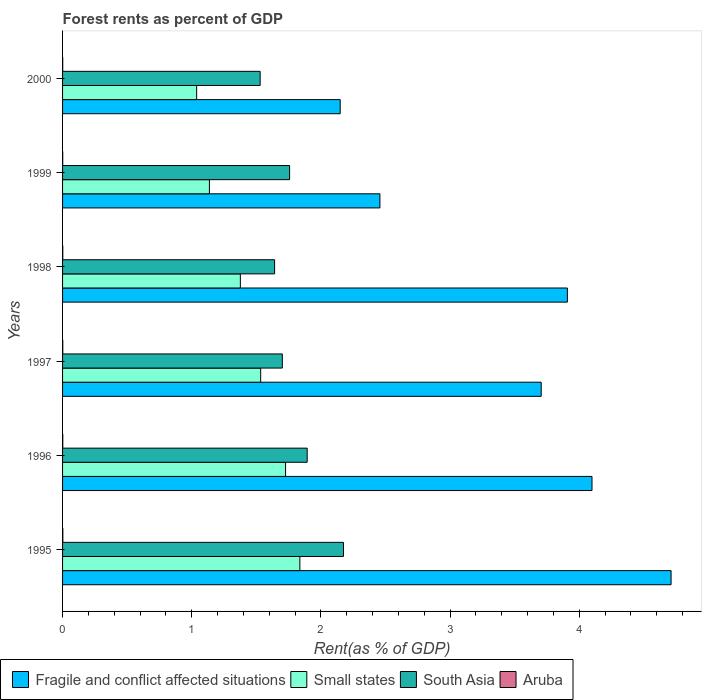How many groups of bars are there?
Your response must be concise. 6. Are the number of bars per tick equal to the number of legend labels?
Your answer should be compact. Yes. Are the number of bars on each tick of the Y-axis equal?
Your response must be concise. Yes. How many bars are there on the 2nd tick from the top?
Give a very brief answer. 4. What is the label of the 2nd group of bars from the top?
Give a very brief answer. 1999. What is the forest rent in Aruba in 1997?
Ensure brevity in your answer.  0. Across all years, what is the maximum forest rent in South Asia?
Give a very brief answer. 2.17. Across all years, what is the minimum forest rent in Aruba?
Offer a very short reply. 0. In which year was the forest rent in South Asia maximum?
Your response must be concise. 1995. What is the total forest rent in Small states in the graph?
Provide a succinct answer. 8.65. What is the difference between the forest rent in Aruba in 1997 and that in 2000?
Your answer should be very brief. 0. What is the difference between the forest rent in Aruba in 1997 and the forest rent in Small states in 1999?
Provide a succinct answer. -1.14. What is the average forest rent in Fragile and conflict affected situations per year?
Make the answer very short. 3.5. In the year 1996, what is the difference between the forest rent in South Asia and forest rent in Aruba?
Ensure brevity in your answer.  1.89. In how many years, is the forest rent in Fragile and conflict affected situations greater than 0.4 %?
Ensure brevity in your answer.  6. What is the ratio of the forest rent in South Asia in 1999 to that in 2000?
Your answer should be very brief. 1.15. What is the difference between the highest and the second highest forest rent in Fragile and conflict affected situations?
Provide a short and direct response. 0.61. What is the difference between the highest and the lowest forest rent in South Asia?
Your answer should be compact. 0.65. In how many years, is the forest rent in Aruba greater than the average forest rent in Aruba taken over all years?
Provide a succinct answer. 4. What does the 1st bar from the bottom in 1998 represents?
Your response must be concise. Fragile and conflict affected situations. Is it the case that in every year, the sum of the forest rent in Aruba and forest rent in Small states is greater than the forest rent in Fragile and conflict affected situations?
Your response must be concise. No. How many bars are there?
Provide a short and direct response. 24. Are all the bars in the graph horizontal?
Your response must be concise. Yes. How many years are there in the graph?
Offer a very short reply. 6. Does the graph contain any zero values?
Your answer should be compact. No. Does the graph contain grids?
Offer a very short reply. No. Where does the legend appear in the graph?
Your response must be concise. Bottom left. How many legend labels are there?
Your answer should be compact. 4. What is the title of the graph?
Your answer should be compact. Forest rents as percent of GDP. Does "Burundi" appear as one of the legend labels in the graph?
Your answer should be compact. No. What is the label or title of the X-axis?
Offer a terse response. Rent(as % of GDP). What is the label or title of the Y-axis?
Make the answer very short. Years. What is the Rent(as % of GDP) in Fragile and conflict affected situations in 1995?
Make the answer very short. 4.71. What is the Rent(as % of GDP) of Small states in 1995?
Provide a short and direct response. 1.84. What is the Rent(as % of GDP) in South Asia in 1995?
Your response must be concise. 2.17. What is the Rent(as % of GDP) in Aruba in 1995?
Provide a short and direct response. 0. What is the Rent(as % of GDP) of Fragile and conflict affected situations in 1996?
Provide a succinct answer. 4.1. What is the Rent(as % of GDP) in Small states in 1996?
Provide a succinct answer. 1.73. What is the Rent(as % of GDP) in South Asia in 1996?
Give a very brief answer. 1.89. What is the Rent(as % of GDP) of Aruba in 1996?
Your response must be concise. 0. What is the Rent(as % of GDP) of Fragile and conflict affected situations in 1997?
Provide a short and direct response. 3.71. What is the Rent(as % of GDP) in Small states in 1997?
Ensure brevity in your answer.  1.53. What is the Rent(as % of GDP) in South Asia in 1997?
Your response must be concise. 1.7. What is the Rent(as % of GDP) in Aruba in 1997?
Keep it short and to the point. 0. What is the Rent(as % of GDP) in Fragile and conflict affected situations in 1998?
Your answer should be very brief. 3.91. What is the Rent(as % of GDP) of Small states in 1998?
Offer a terse response. 1.38. What is the Rent(as % of GDP) in South Asia in 1998?
Offer a very short reply. 1.64. What is the Rent(as % of GDP) of Aruba in 1998?
Give a very brief answer. 0. What is the Rent(as % of GDP) of Fragile and conflict affected situations in 1999?
Offer a terse response. 2.46. What is the Rent(as % of GDP) of Small states in 1999?
Keep it short and to the point. 1.14. What is the Rent(as % of GDP) of South Asia in 1999?
Provide a succinct answer. 1.76. What is the Rent(as % of GDP) of Aruba in 1999?
Your answer should be very brief. 0. What is the Rent(as % of GDP) of Fragile and conflict affected situations in 2000?
Your response must be concise. 2.15. What is the Rent(as % of GDP) in Small states in 2000?
Ensure brevity in your answer.  1.04. What is the Rent(as % of GDP) of South Asia in 2000?
Your response must be concise. 1.53. What is the Rent(as % of GDP) of Aruba in 2000?
Offer a terse response. 0. Across all years, what is the maximum Rent(as % of GDP) in Fragile and conflict affected situations?
Provide a succinct answer. 4.71. Across all years, what is the maximum Rent(as % of GDP) in Small states?
Offer a very short reply. 1.84. Across all years, what is the maximum Rent(as % of GDP) in South Asia?
Provide a short and direct response. 2.17. Across all years, what is the maximum Rent(as % of GDP) in Aruba?
Your answer should be compact. 0. Across all years, what is the minimum Rent(as % of GDP) of Fragile and conflict affected situations?
Your answer should be compact. 2.15. Across all years, what is the minimum Rent(as % of GDP) in Small states?
Keep it short and to the point. 1.04. Across all years, what is the minimum Rent(as % of GDP) of South Asia?
Offer a very short reply. 1.53. Across all years, what is the minimum Rent(as % of GDP) of Aruba?
Ensure brevity in your answer.  0. What is the total Rent(as % of GDP) of Fragile and conflict affected situations in the graph?
Your answer should be very brief. 21.03. What is the total Rent(as % of GDP) in Small states in the graph?
Give a very brief answer. 8.65. What is the total Rent(as % of GDP) of South Asia in the graph?
Provide a short and direct response. 10.7. What is the total Rent(as % of GDP) of Aruba in the graph?
Your response must be concise. 0.01. What is the difference between the Rent(as % of GDP) of Fragile and conflict affected situations in 1995 and that in 1996?
Make the answer very short. 0.61. What is the difference between the Rent(as % of GDP) in Small states in 1995 and that in 1996?
Keep it short and to the point. 0.11. What is the difference between the Rent(as % of GDP) in South Asia in 1995 and that in 1996?
Provide a short and direct response. 0.28. What is the difference between the Rent(as % of GDP) in Fragile and conflict affected situations in 1995 and that in 1997?
Offer a very short reply. 1.01. What is the difference between the Rent(as % of GDP) in Small states in 1995 and that in 1997?
Offer a very short reply. 0.3. What is the difference between the Rent(as % of GDP) of South Asia in 1995 and that in 1997?
Give a very brief answer. 0.47. What is the difference between the Rent(as % of GDP) in Fragile and conflict affected situations in 1995 and that in 1998?
Keep it short and to the point. 0.8. What is the difference between the Rent(as % of GDP) in Small states in 1995 and that in 1998?
Offer a very short reply. 0.46. What is the difference between the Rent(as % of GDP) in South Asia in 1995 and that in 1998?
Offer a terse response. 0.53. What is the difference between the Rent(as % of GDP) in Fragile and conflict affected situations in 1995 and that in 1999?
Offer a terse response. 2.25. What is the difference between the Rent(as % of GDP) of Small states in 1995 and that in 1999?
Your answer should be compact. 0.7. What is the difference between the Rent(as % of GDP) of South Asia in 1995 and that in 1999?
Provide a succinct answer. 0.42. What is the difference between the Rent(as % of GDP) in Aruba in 1995 and that in 1999?
Provide a short and direct response. 0. What is the difference between the Rent(as % of GDP) in Fragile and conflict affected situations in 1995 and that in 2000?
Keep it short and to the point. 2.56. What is the difference between the Rent(as % of GDP) of Small states in 1995 and that in 2000?
Your answer should be very brief. 0.8. What is the difference between the Rent(as % of GDP) of South Asia in 1995 and that in 2000?
Your answer should be compact. 0.65. What is the difference between the Rent(as % of GDP) in Aruba in 1995 and that in 2000?
Offer a terse response. 0. What is the difference between the Rent(as % of GDP) of Fragile and conflict affected situations in 1996 and that in 1997?
Provide a succinct answer. 0.39. What is the difference between the Rent(as % of GDP) in Small states in 1996 and that in 1997?
Your response must be concise. 0.19. What is the difference between the Rent(as % of GDP) of South Asia in 1996 and that in 1997?
Provide a short and direct response. 0.19. What is the difference between the Rent(as % of GDP) of Aruba in 1996 and that in 1997?
Provide a succinct answer. -0. What is the difference between the Rent(as % of GDP) of Fragile and conflict affected situations in 1996 and that in 1998?
Your response must be concise. 0.19. What is the difference between the Rent(as % of GDP) of Small states in 1996 and that in 1998?
Provide a short and direct response. 0.35. What is the difference between the Rent(as % of GDP) in South Asia in 1996 and that in 1998?
Your answer should be compact. 0.25. What is the difference between the Rent(as % of GDP) of Fragile and conflict affected situations in 1996 and that in 1999?
Give a very brief answer. 1.64. What is the difference between the Rent(as % of GDP) of Small states in 1996 and that in 1999?
Your response must be concise. 0.59. What is the difference between the Rent(as % of GDP) in South Asia in 1996 and that in 1999?
Your answer should be compact. 0.14. What is the difference between the Rent(as % of GDP) in Fragile and conflict affected situations in 1996 and that in 2000?
Provide a succinct answer. 1.95. What is the difference between the Rent(as % of GDP) of Small states in 1996 and that in 2000?
Provide a succinct answer. 0.69. What is the difference between the Rent(as % of GDP) of South Asia in 1996 and that in 2000?
Offer a very short reply. 0.36. What is the difference between the Rent(as % of GDP) in Aruba in 1996 and that in 2000?
Offer a very short reply. 0. What is the difference between the Rent(as % of GDP) of Fragile and conflict affected situations in 1997 and that in 1998?
Your response must be concise. -0.2. What is the difference between the Rent(as % of GDP) in Small states in 1997 and that in 1998?
Offer a terse response. 0.16. What is the difference between the Rent(as % of GDP) in South Asia in 1997 and that in 1998?
Provide a succinct answer. 0.06. What is the difference between the Rent(as % of GDP) in Fragile and conflict affected situations in 1997 and that in 1999?
Provide a succinct answer. 1.25. What is the difference between the Rent(as % of GDP) of Small states in 1997 and that in 1999?
Provide a short and direct response. 0.4. What is the difference between the Rent(as % of GDP) of South Asia in 1997 and that in 1999?
Your answer should be compact. -0.06. What is the difference between the Rent(as % of GDP) in Aruba in 1997 and that in 1999?
Your answer should be compact. 0. What is the difference between the Rent(as % of GDP) in Fragile and conflict affected situations in 1997 and that in 2000?
Your response must be concise. 1.56. What is the difference between the Rent(as % of GDP) of Small states in 1997 and that in 2000?
Your response must be concise. 0.5. What is the difference between the Rent(as % of GDP) of South Asia in 1997 and that in 2000?
Provide a succinct answer. 0.17. What is the difference between the Rent(as % of GDP) in Fragile and conflict affected situations in 1998 and that in 1999?
Offer a terse response. 1.45. What is the difference between the Rent(as % of GDP) in Small states in 1998 and that in 1999?
Your answer should be very brief. 0.24. What is the difference between the Rent(as % of GDP) of South Asia in 1998 and that in 1999?
Make the answer very short. -0.12. What is the difference between the Rent(as % of GDP) in Aruba in 1998 and that in 1999?
Ensure brevity in your answer.  0. What is the difference between the Rent(as % of GDP) in Fragile and conflict affected situations in 1998 and that in 2000?
Provide a short and direct response. 1.76. What is the difference between the Rent(as % of GDP) of Small states in 1998 and that in 2000?
Give a very brief answer. 0.34. What is the difference between the Rent(as % of GDP) of South Asia in 1998 and that in 2000?
Your response must be concise. 0.11. What is the difference between the Rent(as % of GDP) of Aruba in 1998 and that in 2000?
Keep it short and to the point. 0. What is the difference between the Rent(as % of GDP) of Fragile and conflict affected situations in 1999 and that in 2000?
Your response must be concise. 0.31. What is the difference between the Rent(as % of GDP) of Small states in 1999 and that in 2000?
Your answer should be compact. 0.1. What is the difference between the Rent(as % of GDP) in South Asia in 1999 and that in 2000?
Your response must be concise. 0.23. What is the difference between the Rent(as % of GDP) in Fragile and conflict affected situations in 1995 and the Rent(as % of GDP) in Small states in 1996?
Your answer should be compact. 2.98. What is the difference between the Rent(as % of GDP) in Fragile and conflict affected situations in 1995 and the Rent(as % of GDP) in South Asia in 1996?
Ensure brevity in your answer.  2.82. What is the difference between the Rent(as % of GDP) of Fragile and conflict affected situations in 1995 and the Rent(as % of GDP) of Aruba in 1996?
Your response must be concise. 4.71. What is the difference between the Rent(as % of GDP) of Small states in 1995 and the Rent(as % of GDP) of South Asia in 1996?
Ensure brevity in your answer.  -0.06. What is the difference between the Rent(as % of GDP) of Small states in 1995 and the Rent(as % of GDP) of Aruba in 1996?
Your answer should be very brief. 1.84. What is the difference between the Rent(as % of GDP) of South Asia in 1995 and the Rent(as % of GDP) of Aruba in 1996?
Offer a terse response. 2.17. What is the difference between the Rent(as % of GDP) of Fragile and conflict affected situations in 1995 and the Rent(as % of GDP) of Small states in 1997?
Offer a very short reply. 3.18. What is the difference between the Rent(as % of GDP) of Fragile and conflict affected situations in 1995 and the Rent(as % of GDP) of South Asia in 1997?
Provide a succinct answer. 3.01. What is the difference between the Rent(as % of GDP) of Fragile and conflict affected situations in 1995 and the Rent(as % of GDP) of Aruba in 1997?
Your answer should be very brief. 4.71. What is the difference between the Rent(as % of GDP) of Small states in 1995 and the Rent(as % of GDP) of South Asia in 1997?
Provide a short and direct response. 0.14. What is the difference between the Rent(as % of GDP) of Small states in 1995 and the Rent(as % of GDP) of Aruba in 1997?
Keep it short and to the point. 1.84. What is the difference between the Rent(as % of GDP) in South Asia in 1995 and the Rent(as % of GDP) in Aruba in 1997?
Offer a terse response. 2.17. What is the difference between the Rent(as % of GDP) of Fragile and conflict affected situations in 1995 and the Rent(as % of GDP) of Small states in 1998?
Your answer should be compact. 3.33. What is the difference between the Rent(as % of GDP) in Fragile and conflict affected situations in 1995 and the Rent(as % of GDP) in South Asia in 1998?
Your answer should be compact. 3.07. What is the difference between the Rent(as % of GDP) of Fragile and conflict affected situations in 1995 and the Rent(as % of GDP) of Aruba in 1998?
Ensure brevity in your answer.  4.71. What is the difference between the Rent(as % of GDP) in Small states in 1995 and the Rent(as % of GDP) in South Asia in 1998?
Offer a terse response. 0.2. What is the difference between the Rent(as % of GDP) in Small states in 1995 and the Rent(as % of GDP) in Aruba in 1998?
Keep it short and to the point. 1.84. What is the difference between the Rent(as % of GDP) in South Asia in 1995 and the Rent(as % of GDP) in Aruba in 1998?
Your answer should be compact. 2.17. What is the difference between the Rent(as % of GDP) in Fragile and conflict affected situations in 1995 and the Rent(as % of GDP) in Small states in 1999?
Provide a short and direct response. 3.57. What is the difference between the Rent(as % of GDP) of Fragile and conflict affected situations in 1995 and the Rent(as % of GDP) of South Asia in 1999?
Keep it short and to the point. 2.95. What is the difference between the Rent(as % of GDP) in Fragile and conflict affected situations in 1995 and the Rent(as % of GDP) in Aruba in 1999?
Provide a short and direct response. 4.71. What is the difference between the Rent(as % of GDP) in Small states in 1995 and the Rent(as % of GDP) in South Asia in 1999?
Make the answer very short. 0.08. What is the difference between the Rent(as % of GDP) in Small states in 1995 and the Rent(as % of GDP) in Aruba in 1999?
Keep it short and to the point. 1.84. What is the difference between the Rent(as % of GDP) in South Asia in 1995 and the Rent(as % of GDP) in Aruba in 1999?
Make the answer very short. 2.17. What is the difference between the Rent(as % of GDP) in Fragile and conflict affected situations in 1995 and the Rent(as % of GDP) in Small states in 2000?
Make the answer very short. 3.67. What is the difference between the Rent(as % of GDP) of Fragile and conflict affected situations in 1995 and the Rent(as % of GDP) of South Asia in 2000?
Give a very brief answer. 3.18. What is the difference between the Rent(as % of GDP) in Fragile and conflict affected situations in 1995 and the Rent(as % of GDP) in Aruba in 2000?
Keep it short and to the point. 4.71. What is the difference between the Rent(as % of GDP) of Small states in 1995 and the Rent(as % of GDP) of South Asia in 2000?
Ensure brevity in your answer.  0.31. What is the difference between the Rent(as % of GDP) of Small states in 1995 and the Rent(as % of GDP) of Aruba in 2000?
Give a very brief answer. 1.84. What is the difference between the Rent(as % of GDP) in South Asia in 1995 and the Rent(as % of GDP) in Aruba in 2000?
Your response must be concise. 2.17. What is the difference between the Rent(as % of GDP) in Fragile and conflict affected situations in 1996 and the Rent(as % of GDP) in Small states in 1997?
Offer a terse response. 2.57. What is the difference between the Rent(as % of GDP) of Fragile and conflict affected situations in 1996 and the Rent(as % of GDP) of South Asia in 1997?
Provide a succinct answer. 2.4. What is the difference between the Rent(as % of GDP) of Fragile and conflict affected situations in 1996 and the Rent(as % of GDP) of Aruba in 1997?
Offer a very short reply. 4.1. What is the difference between the Rent(as % of GDP) of Small states in 1996 and the Rent(as % of GDP) of South Asia in 1997?
Keep it short and to the point. 0.03. What is the difference between the Rent(as % of GDP) in Small states in 1996 and the Rent(as % of GDP) in Aruba in 1997?
Keep it short and to the point. 1.72. What is the difference between the Rent(as % of GDP) in South Asia in 1996 and the Rent(as % of GDP) in Aruba in 1997?
Provide a succinct answer. 1.89. What is the difference between the Rent(as % of GDP) in Fragile and conflict affected situations in 1996 and the Rent(as % of GDP) in Small states in 1998?
Give a very brief answer. 2.72. What is the difference between the Rent(as % of GDP) in Fragile and conflict affected situations in 1996 and the Rent(as % of GDP) in South Asia in 1998?
Your response must be concise. 2.46. What is the difference between the Rent(as % of GDP) in Fragile and conflict affected situations in 1996 and the Rent(as % of GDP) in Aruba in 1998?
Keep it short and to the point. 4.1. What is the difference between the Rent(as % of GDP) of Small states in 1996 and the Rent(as % of GDP) of South Asia in 1998?
Give a very brief answer. 0.08. What is the difference between the Rent(as % of GDP) in Small states in 1996 and the Rent(as % of GDP) in Aruba in 1998?
Keep it short and to the point. 1.72. What is the difference between the Rent(as % of GDP) of South Asia in 1996 and the Rent(as % of GDP) of Aruba in 1998?
Provide a short and direct response. 1.89. What is the difference between the Rent(as % of GDP) in Fragile and conflict affected situations in 1996 and the Rent(as % of GDP) in Small states in 1999?
Your answer should be very brief. 2.96. What is the difference between the Rent(as % of GDP) of Fragile and conflict affected situations in 1996 and the Rent(as % of GDP) of South Asia in 1999?
Your response must be concise. 2.34. What is the difference between the Rent(as % of GDP) in Fragile and conflict affected situations in 1996 and the Rent(as % of GDP) in Aruba in 1999?
Your answer should be very brief. 4.1. What is the difference between the Rent(as % of GDP) of Small states in 1996 and the Rent(as % of GDP) of South Asia in 1999?
Provide a succinct answer. -0.03. What is the difference between the Rent(as % of GDP) of Small states in 1996 and the Rent(as % of GDP) of Aruba in 1999?
Make the answer very short. 1.73. What is the difference between the Rent(as % of GDP) in South Asia in 1996 and the Rent(as % of GDP) in Aruba in 1999?
Provide a short and direct response. 1.89. What is the difference between the Rent(as % of GDP) of Fragile and conflict affected situations in 1996 and the Rent(as % of GDP) of Small states in 2000?
Make the answer very short. 3.06. What is the difference between the Rent(as % of GDP) of Fragile and conflict affected situations in 1996 and the Rent(as % of GDP) of South Asia in 2000?
Make the answer very short. 2.57. What is the difference between the Rent(as % of GDP) of Fragile and conflict affected situations in 1996 and the Rent(as % of GDP) of Aruba in 2000?
Offer a very short reply. 4.1. What is the difference between the Rent(as % of GDP) in Small states in 1996 and the Rent(as % of GDP) in South Asia in 2000?
Ensure brevity in your answer.  0.2. What is the difference between the Rent(as % of GDP) of Small states in 1996 and the Rent(as % of GDP) of Aruba in 2000?
Make the answer very short. 1.73. What is the difference between the Rent(as % of GDP) of South Asia in 1996 and the Rent(as % of GDP) of Aruba in 2000?
Your answer should be very brief. 1.89. What is the difference between the Rent(as % of GDP) in Fragile and conflict affected situations in 1997 and the Rent(as % of GDP) in Small states in 1998?
Make the answer very short. 2.33. What is the difference between the Rent(as % of GDP) in Fragile and conflict affected situations in 1997 and the Rent(as % of GDP) in South Asia in 1998?
Your response must be concise. 2.06. What is the difference between the Rent(as % of GDP) of Fragile and conflict affected situations in 1997 and the Rent(as % of GDP) of Aruba in 1998?
Provide a succinct answer. 3.7. What is the difference between the Rent(as % of GDP) in Small states in 1997 and the Rent(as % of GDP) in South Asia in 1998?
Your answer should be very brief. -0.11. What is the difference between the Rent(as % of GDP) in Small states in 1997 and the Rent(as % of GDP) in Aruba in 1998?
Your response must be concise. 1.53. What is the difference between the Rent(as % of GDP) in South Asia in 1997 and the Rent(as % of GDP) in Aruba in 1998?
Your answer should be very brief. 1.7. What is the difference between the Rent(as % of GDP) of Fragile and conflict affected situations in 1997 and the Rent(as % of GDP) of Small states in 1999?
Provide a succinct answer. 2.57. What is the difference between the Rent(as % of GDP) of Fragile and conflict affected situations in 1997 and the Rent(as % of GDP) of South Asia in 1999?
Provide a short and direct response. 1.95. What is the difference between the Rent(as % of GDP) of Fragile and conflict affected situations in 1997 and the Rent(as % of GDP) of Aruba in 1999?
Offer a terse response. 3.7. What is the difference between the Rent(as % of GDP) of Small states in 1997 and the Rent(as % of GDP) of South Asia in 1999?
Your response must be concise. -0.22. What is the difference between the Rent(as % of GDP) of Small states in 1997 and the Rent(as % of GDP) of Aruba in 1999?
Offer a terse response. 1.53. What is the difference between the Rent(as % of GDP) of South Asia in 1997 and the Rent(as % of GDP) of Aruba in 1999?
Keep it short and to the point. 1.7. What is the difference between the Rent(as % of GDP) in Fragile and conflict affected situations in 1997 and the Rent(as % of GDP) in Small states in 2000?
Your response must be concise. 2.67. What is the difference between the Rent(as % of GDP) in Fragile and conflict affected situations in 1997 and the Rent(as % of GDP) in South Asia in 2000?
Make the answer very short. 2.18. What is the difference between the Rent(as % of GDP) of Fragile and conflict affected situations in 1997 and the Rent(as % of GDP) of Aruba in 2000?
Your response must be concise. 3.7. What is the difference between the Rent(as % of GDP) in Small states in 1997 and the Rent(as % of GDP) in South Asia in 2000?
Provide a succinct answer. 0. What is the difference between the Rent(as % of GDP) of Small states in 1997 and the Rent(as % of GDP) of Aruba in 2000?
Make the answer very short. 1.53. What is the difference between the Rent(as % of GDP) in South Asia in 1997 and the Rent(as % of GDP) in Aruba in 2000?
Provide a succinct answer. 1.7. What is the difference between the Rent(as % of GDP) of Fragile and conflict affected situations in 1998 and the Rent(as % of GDP) of Small states in 1999?
Give a very brief answer. 2.77. What is the difference between the Rent(as % of GDP) in Fragile and conflict affected situations in 1998 and the Rent(as % of GDP) in South Asia in 1999?
Provide a succinct answer. 2.15. What is the difference between the Rent(as % of GDP) in Fragile and conflict affected situations in 1998 and the Rent(as % of GDP) in Aruba in 1999?
Provide a succinct answer. 3.91. What is the difference between the Rent(as % of GDP) in Small states in 1998 and the Rent(as % of GDP) in South Asia in 1999?
Give a very brief answer. -0.38. What is the difference between the Rent(as % of GDP) of Small states in 1998 and the Rent(as % of GDP) of Aruba in 1999?
Provide a succinct answer. 1.38. What is the difference between the Rent(as % of GDP) of South Asia in 1998 and the Rent(as % of GDP) of Aruba in 1999?
Offer a very short reply. 1.64. What is the difference between the Rent(as % of GDP) of Fragile and conflict affected situations in 1998 and the Rent(as % of GDP) of Small states in 2000?
Give a very brief answer. 2.87. What is the difference between the Rent(as % of GDP) of Fragile and conflict affected situations in 1998 and the Rent(as % of GDP) of South Asia in 2000?
Provide a succinct answer. 2.38. What is the difference between the Rent(as % of GDP) in Fragile and conflict affected situations in 1998 and the Rent(as % of GDP) in Aruba in 2000?
Offer a very short reply. 3.91. What is the difference between the Rent(as % of GDP) of Small states in 1998 and the Rent(as % of GDP) of South Asia in 2000?
Your answer should be compact. -0.15. What is the difference between the Rent(as % of GDP) in Small states in 1998 and the Rent(as % of GDP) in Aruba in 2000?
Your response must be concise. 1.38. What is the difference between the Rent(as % of GDP) of South Asia in 1998 and the Rent(as % of GDP) of Aruba in 2000?
Your answer should be very brief. 1.64. What is the difference between the Rent(as % of GDP) in Fragile and conflict affected situations in 1999 and the Rent(as % of GDP) in Small states in 2000?
Your response must be concise. 1.42. What is the difference between the Rent(as % of GDP) in Fragile and conflict affected situations in 1999 and the Rent(as % of GDP) in South Asia in 2000?
Give a very brief answer. 0.93. What is the difference between the Rent(as % of GDP) in Fragile and conflict affected situations in 1999 and the Rent(as % of GDP) in Aruba in 2000?
Your response must be concise. 2.46. What is the difference between the Rent(as % of GDP) of Small states in 1999 and the Rent(as % of GDP) of South Asia in 2000?
Provide a short and direct response. -0.39. What is the difference between the Rent(as % of GDP) in Small states in 1999 and the Rent(as % of GDP) in Aruba in 2000?
Provide a succinct answer. 1.14. What is the difference between the Rent(as % of GDP) of South Asia in 1999 and the Rent(as % of GDP) of Aruba in 2000?
Your answer should be compact. 1.76. What is the average Rent(as % of GDP) of Fragile and conflict affected situations per year?
Provide a short and direct response. 3.5. What is the average Rent(as % of GDP) of Small states per year?
Your answer should be very brief. 1.44. What is the average Rent(as % of GDP) of South Asia per year?
Provide a succinct answer. 1.78. What is the average Rent(as % of GDP) in Aruba per year?
Your answer should be very brief. 0. In the year 1995, what is the difference between the Rent(as % of GDP) in Fragile and conflict affected situations and Rent(as % of GDP) in Small states?
Provide a short and direct response. 2.87. In the year 1995, what is the difference between the Rent(as % of GDP) of Fragile and conflict affected situations and Rent(as % of GDP) of South Asia?
Provide a succinct answer. 2.54. In the year 1995, what is the difference between the Rent(as % of GDP) of Fragile and conflict affected situations and Rent(as % of GDP) of Aruba?
Keep it short and to the point. 4.71. In the year 1995, what is the difference between the Rent(as % of GDP) of Small states and Rent(as % of GDP) of South Asia?
Offer a terse response. -0.34. In the year 1995, what is the difference between the Rent(as % of GDP) of Small states and Rent(as % of GDP) of Aruba?
Make the answer very short. 1.83. In the year 1995, what is the difference between the Rent(as % of GDP) in South Asia and Rent(as % of GDP) in Aruba?
Offer a terse response. 2.17. In the year 1996, what is the difference between the Rent(as % of GDP) in Fragile and conflict affected situations and Rent(as % of GDP) in Small states?
Your response must be concise. 2.37. In the year 1996, what is the difference between the Rent(as % of GDP) of Fragile and conflict affected situations and Rent(as % of GDP) of South Asia?
Provide a succinct answer. 2.21. In the year 1996, what is the difference between the Rent(as % of GDP) of Fragile and conflict affected situations and Rent(as % of GDP) of Aruba?
Ensure brevity in your answer.  4.1. In the year 1996, what is the difference between the Rent(as % of GDP) of Small states and Rent(as % of GDP) of South Asia?
Make the answer very short. -0.17. In the year 1996, what is the difference between the Rent(as % of GDP) in Small states and Rent(as % of GDP) in Aruba?
Keep it short and to the point. 1.72. In the year 1996, what is the difference between the Rent(as % of GDP) in South Asia and Rent(as % of GDP) in Aruba?
Your response must be concise. 1.89. In the year 1997, what is the difference between the Rent(as % of GDP) in Fragile and conflict affected situations and Rent(as % of GDP) in Small states?
Provide a short and direct response. 2.17. In the year 1997, what is the difference between the Rent(as % of GDP) of Fragile and conflict affected situations and Rent(as % of GDP) of South Asia?
Your answer should be very brief. 2. In the year 1997, what is the difference between the Rent(as % of GDP) in Fragile and conflict affected situations and Rent(as % of GDP) in Aruba?
Offer a very short reply. 3.7. In the year 1997, what is the difference between the Rent(as % of GDP) in Small states and Rent(as % of GDP) in South Asia?
Ensure brevity in your answer.  -0.17. In the year 1997, what is the difference between the Rent(as % of GDP) of Small states and Rent(as % of GDP) of Aruba?
Give a very brief answer. 1.53. In the year 1997, what is the difference between the Rent(as % of GDP) of South Asia and Rent(as % of GDP) of Aruba?
Ensure brevity in your answer.  1.7. In the year 1998, what is the difference between the Rent(as % of GDP) in Fragile and conflict affected situations and Rent(as % of GDP) in Small states?
Your answer should be compact. 2.53. In the year 1998, what is the difference between the Rent(as % of GDP) of Fragile and conflict affected situations and Rent(as % of GDP) of South Asia?
Offer a very short reply. 2.27. In the year 1998, what is the difference between the Rent(as % of GDP) in Fragile and conflict affected situations and Rent(as % of GDP) in Aruba?
Your answer should be very brief. 3.91. In the year 1998, what is the difference between the Rent(as % of GDP) in Small states and Rent(as % of GDP) in South Asia?
Keep it short and to the point. -0.27. In the year 1998, what is the difference between the Rent(as % of GDP) in Small states and Rent(as % of GDP) in Aruba?
Provide a succinct answer. 1.37. In the year 1998, what is the difference between the Rent(as % of GDP) in South Asia and Rent(as % of GDP) in Aruba?
Provide a short and direct response. 1.64. In the year 1999, what is the difference between the Rent(as % of GDP) of Fragile and conflict affected situations and Rent(as % of GDP) of Small states?
Give a very brief answer. 1.32. In the year 1999, what is the difference between the Rent(as % of GDP) of Fragile and conflict affected situations and Rent(as % of GDP) of South Asia?
Your answer should be compact. 0.7. In the year 1999, what is the difference between the Rent(as % of GDP) in Fragile and conflict affected situations and Rent(as % of GDP) in Aruba?
Make the answer very short. 2.46. In the year 1999, what is the difference between the Rent(as % of GDP) of Small states and Rent(as % of GDP) of South Asia?
Offer a terse response. -0.62. In the year 1999, what is the difference between the Rent(as % of GDP) of Small states and Rent(as % of GDP) of Aruba?
Provide a short and direct response. 1.14. In the year 1999, what is the difference between the Rent(as % of GDP) in South Asia and Rent(as % of GDP) in Aruba?
Ensure brevity in your answer.  1.76. In the year 2000, what is the difference between the Rent(as % of GDP) in Fragile and conflict affected situations and Rent(as % of GDP) in Small states?
Ensure brevity in your answer.  1.11. In the year 2000, what is the difference between the Rent(as % of GDP) in Fragile and conflict affected situations and Rent(as % of GDP) in South Asia?
Provide a succinct answer. 0.62. In the year 2000, what is the difference between the Rent(as % of GDP) in Fragile and conflict affected situations and Rent(as % of GDP) in Aruba?
Provide a succinct answer. 2.15. In the year 2000, what is the difference between the Rent(as % of GDP) of Small states and Rent(as % of GDP) of South Asia?
Your response must be concise. -0.49. In the year 2000, what is the difference between the Rent(as % of GDP) in Small states and Rent(as % of GDP) in Aruba?
Provide a succinct answer. 1.04. In the year 2000, what is the difference between the Rent(as % of GDP) in South Asia and Rent(as % of GDP) in Aruba?
Your answer should be compact. 1.53. What is the ratio of the Rent(as % of GDP) in Fragile and conflict affected situations in 1995 to that in 1996?
Ensure brevity in your answer.  1.15. What is the ratio of the Rent(as % of GDP) in Small states in 1995 to that in 1996?
Keep it short and to the point. 1.06. What is the ratio of the Rent(as % of GDP) in South Asia in 1995 to that in 1996?
Offer a very short reply. 1.15. What is the ratio of the Rent(as % of GDP) of Aruba in 1995 to that in 1996?
Offer a terse response. 1.29. What is the ratio of the Rent(as % of GDP) of Fragile and conflict affected situations in 1995 to that in 1997?
Your response must be concise. 1.27. What is the ratio of the Rent(as % of GDP) of Small states in 1995 to that in 1997?
Offer a very short reply. 1.2. What is the ratio of the Rent(as % of GDP) in South Asia in 1995 to that in 1997?
Offer a very short reply. 1.28. What is the ratio of the Rent(as % of GDP) of Aruba in 1995 to that in 1997?
Your answer should be compact. 1.27. What is the ratio of the Rent(as % of GDP) of Fragile and conflict affected situations in 1995 to that in 1998?
Ensure brevity in your answer.  1.21. What is the ratio of the Rent(as % of GDP) of Small states in 1995 to that in 1998?
Provide a succinct answer. 1.33. What is the ratio of the Rent(as % of GDP) of South Asia in 1995 to that in 1998?
Your answer should be compact. 1.32. What is the ratio of the Rent(as % of GDP) of Aruba in 1995 to that in 1998?
Ensure brevity in your answer.  1.3. What is the ratio of the Rent(as % of GDP) in Fragile and conflict affected situations in 1995 to that in 1999?
Provide a short and direct response. 1.92. What is the ratio of the Rent(as % of GDP) of Small states in 1995 to that in 1999?
Your answer should be compact. 1.62. What is the ratio of the Rent(as % of GDP) of South Asia in 1995 to that in 1999?
Make the answer very short. 1.24. What is the ratio of the Rent(as % of GDP) in Aruba in 1995 to that in 1999?
Offer a terse response. 1.76. What is the ratio of the Rent(as % of GDP) of Fragile and conflict affected situations in 1995 to that in 2000?
Offer a very short reply. 2.19. What is the ratio of the Rent(as % of GDP) in Small states in 1995 to that in 2000?
Ensure brevity in your answer.  1.77. What is the ratio of the Rent(as % of GDP) in South Asia in 1995 to that in 2000?
Ensure brevity in your answer.  1.42. What is the ratio of the Rent(as % of GDP) in Aruba in 1995 to that in 2000?
Provide a succinct answer. 1.85. What is the ratio of the Rent(as % of GDP) of Fragile and conflict affected situations in 1996 to that in 1997?
Provide a short and direct response. 1.11. What is the ratio of the Rent(as % of GDP) of Small states in 1996 to that in 1997?
Your response must be concise. 1.13. What is the ratio of the Rent(as % of GDP) in South Asia in 1996 to that in 1997?
Provide a succinct answer. 1.11. What is the ratio of the Rent(as % of GDP) of Aruba in 1996 to that in 1997?
Give a very brief answer. 0.98. What is the ratio of the Rent(as % of GDP) of Fragile and conflict affected situations in 1996 to that in 1998?
Your answer should be compact. 1.05. What is the ratio of the Rent(as % of GDP) in Small states in 1996 to that in 1998?
Keep it short and to the point. 1.25. What is the ratio of the Rent(as % of GDP) of South Asia in 1996 to that in 1998?
Give a very brief answer. 1.15. What is the ratio of the Rent(as % of GDP) of Fragile and conflict affected situations in 1996 to that in 1999?
Offer a terse response. 1.67. What is the ratio of the Rent(as % of GDP) in Small states in 1996 to that in 1999?
Your answer should be compact. 1.52. What is the ratio of the Rent(as % of GDP) of South Asia in 1996 to that in 1999?
Your response must be concise. 1.08. What is the ratio of the Rent(as % of GDP) of Aruba in 1996 to that in 1999?
Give a very brief answer. 1.36. What is the ratio of the Rent(as % of GDP) of Fragile and conflict affected situations in 1996 to that in 2000?
Your response must be concise. 1.91. What is the ratio of the Rent(as % of GDP) in Small states in 1996 to that in 2000?
Offer a very short reply. 1.66. What is the ratio of the Rent(as % of GDP) in South Asia in 1996 to that in 2000?
Make the answer very short. 1.24. What is the ratio of the Rent(as % of GDP) of Aruba in 1996 to that in 2000?
Provide a succinct answer. 1.43. What is the ratio of the Rent(as % of GDP) in Fragile and conflict affected situations in 1997 to that in 1998?
Offer a terse response. 0.95. What is the ratio of the Rent(as % of GDP) of Small states in 1997 to that in 1998?
Keep it short and to the point. 1.11. What is the ratio of the Rent(as % of GDP) of South Asia in 1997 to that in 1998?
Offer a terse response. 1.04. What is the ratio of the Rent(as % of GDP) in Aruba in 1997 to that in 1998?
Give a very brief answer. 1.02. What is the ratio of the Rent(as % of GDP) of Fragile and conflict affected situations in 1997 to that in 1999?
Provide a short and direct response. 1.51. What is the ratio of the Rent(as % of GDP) in Small states in 1997 to that in 1999?
Give a very brief answer. 1.35. What is the ratio of the Rent(as % of GDP) of South Asia in 1997 to that in 1999?
Offer a very short reply. 0.97. What is the ratio of the Rent(as % of GDP) of Aruba in 1997 to that in 1999?
Your answer should be compact. 1.38. What is the ratio of the Rent(as % of GDP) in Fragile and conflict affected situations in 1997 to that in 2000?
Offer a very short reply. 1.72. What is the ratio of the Rent(as % of GDP) in Small states in 1997 to that in 2000?
Your answer should be compact. 1.48. What is the ratio of the Rent(as % of GDP) of South Asia in 1997 to that in 2000?
Your answer should be very brief. 1.11. What is the ratio of the Rent(as % of GDP) of Aruba in 1997 to that in 2000?
Your response must be concise. 1.45. What is the ratio of the Rent(as % of GDP) in Fragile and conflict affected situations in 1998 to that in 1999?
Your response must be concise. 1.59. What is the ratio of the Rent(as % of GDP) in Small states in 1998 to that in 1999?
Offer a very short reply. 1.21. What is the ratio of the Rent(as % of GDP) of South Asia in 1998 to that in 1999?
Your answer should be compact. 0.93. What is the ratio of the Rent(as % of GDP) in Aruba in 1998 to that in 1999?
Give a very brief answer. 1.35. What is the ratio of the Rent(as % of GDP) of Fragile and conflict affected situations in 1998 to that in 2000?
Give a very brief answer. 1.82. What is the ratio of the Rent(as % of GDP) of Small states in 1998 to that in 2000?
Ensure brevity in your answer.  1.33. What is the ratio of the Rent(as % of GDP) in South Asia in 1998 to that in 2000?
Make the answer very short. 1.07. What is the ratio of the Rent(as % of GDP) in Aruba in 1998 to that in 2000?
Give a very brief answer. 1.42. What is the ratio of the Rent(as % of GDP) in Fragile and conflict affected situations in 1999 to that in 2000?
Offer a very short reply. 1.14. What is the ratio of the Rent(as % of GDP) in Small states in 1999 to that in 2000?
Offer a terse response. 1.1. What is the ratio of the Rent(as % of GDP) in South Asia in 1999 to that in 2000?
Keep it short and to the point. 1.15. What is the ratio of the Rent(as % of GDP) of Aruba in 1999 to that in 2000?
Give a very brief answer. 1.05. What is the difference between the highest and the second highest Rent(as % of GDP) in Fragile and conflict affected situations?
Make the answer very short. 0.61. What is the difference between the highest and the second highest Rent(as % of GDP) of Small states?
Offer a very short reply. 0.11. What is the difference between the highest and the second highest Rent(as % of GDP) of South Asia?
Offer a very short reply. 0.28. What is the difference between the highest and the second highest Rent(as % of GDP) of Aruba?
Your answer should be very brief. 0. What is the difference between the highest and the lowest Rent(as % of GDP) in Fragile and conflict affected situations?
Give a very brief answer. 2.56. What is the difference between the highest and the lowest Rent(as % of GDP) in Small states?
Make the answer very short. 0.8. What is the difference between the highest and the lowest Rent(as % of GDP) of South Asia?
Keep it short and to the point. 0.65. 